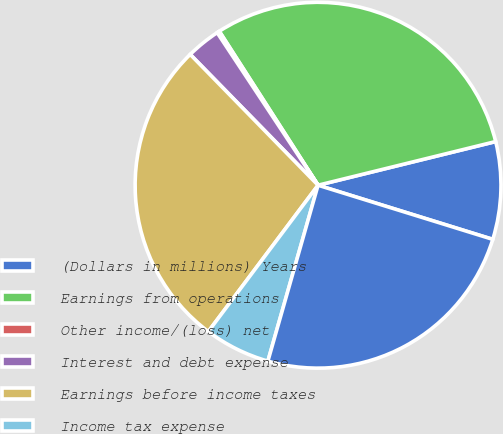Convert chart to OTSL. <chart><loc_0><loc_0><loc_500><loc_500><pie_chart><fcel>(Dollars in millions) Years<fcel>Earnings from operations<fcel>Other income/(loss) net<fcel>Interest and debt expense<fcel>Earnings before income taxes<fcel>Income tax expense<fcel>Net earnings from continuing<nl><fcel>8.62%<fcel>30.24%<fcel>0.22%<fcel>3.02%<fcel>27.44%<fcel>5.82%<fcel>24.64%<nl></chart> 